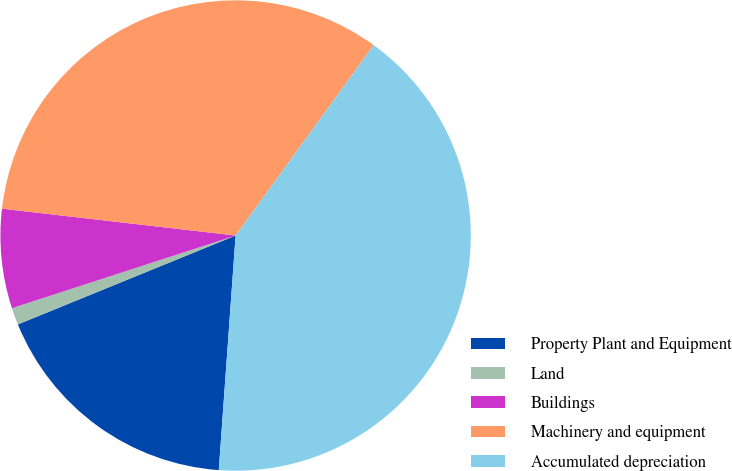Convert chart to OTSL. <chart><loc_0><loc_0><loc_500><loc_500><pie_chart><fcel>Property Plant and Equipment<fcel>Land<fcel>Buildings<fcel>Machinery and equipment<fcel>Accumulated depreciation<nl><fcel>17.69%<fcel>1.17%<fcel>6.82%<fcel>33.16%<fcel>41.15%<nl></chart> 